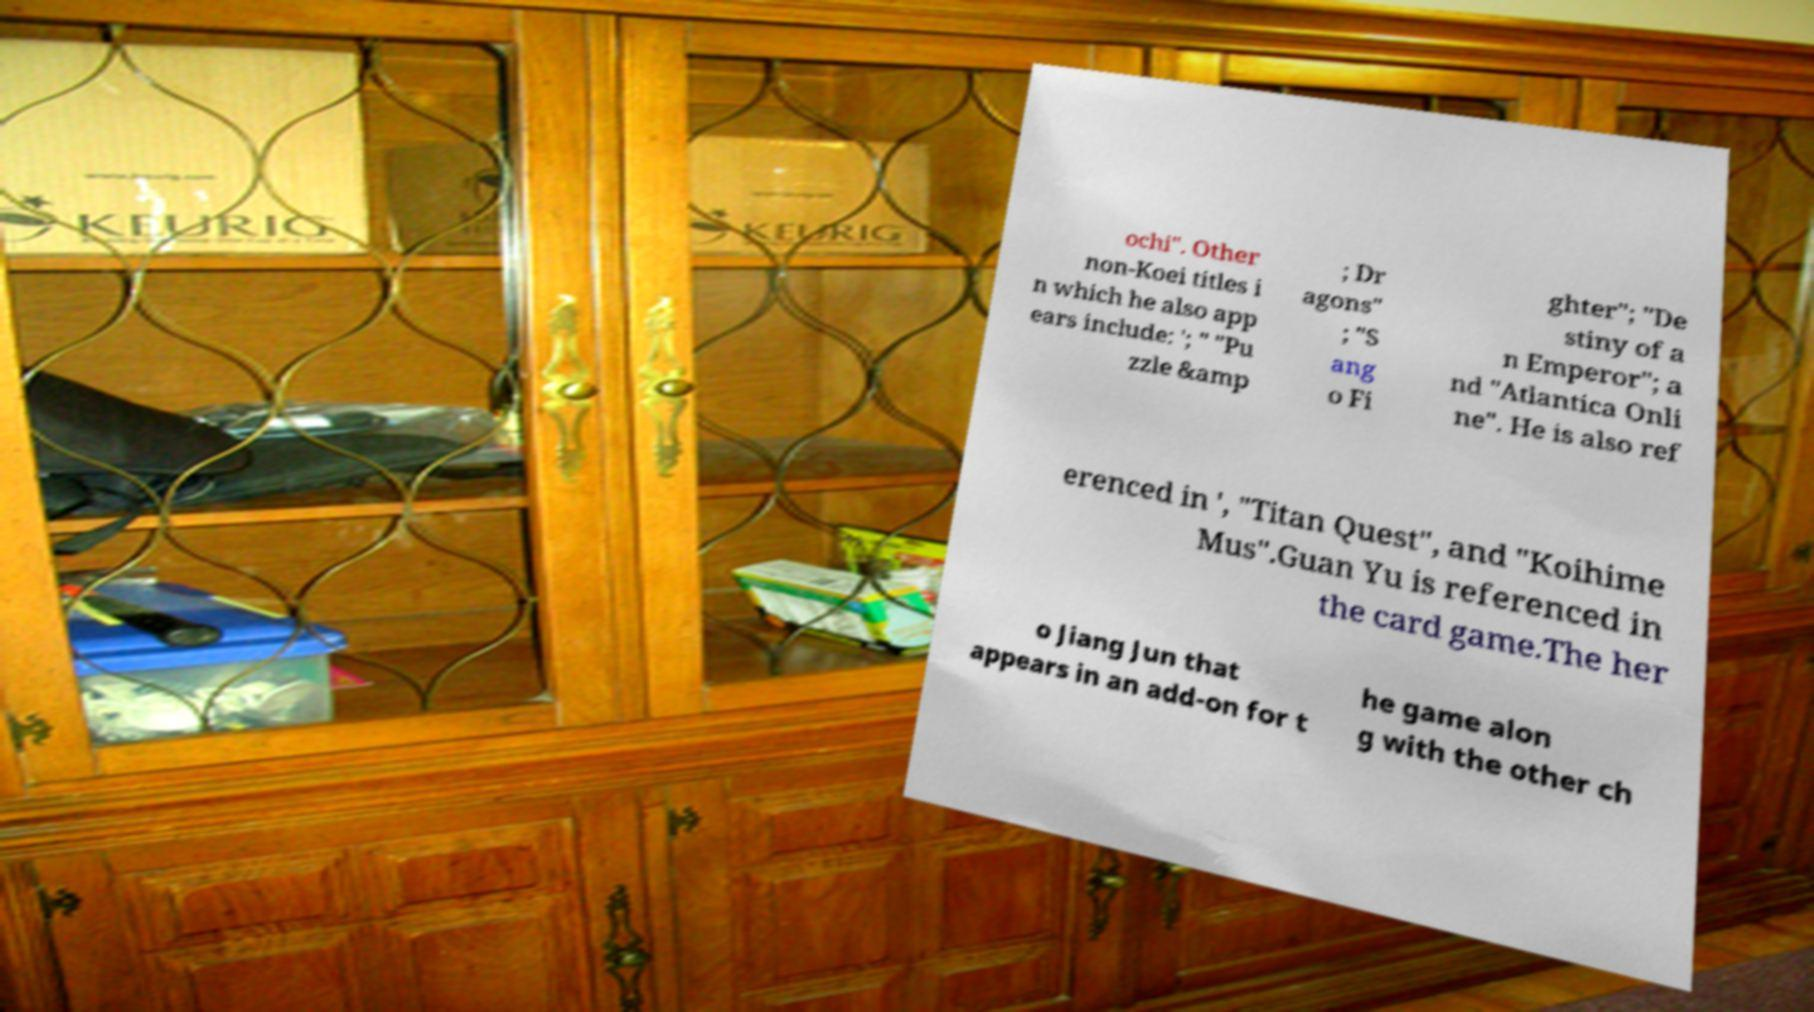There's text embedded in this image that I need extracted. Can you transcribe it verbatim? ochi". Other non-Koei titles i n which he also app ears include: '; " "Pu zzle &amp ; Dr agons" ; "S ang o Fi ghter"; "De stiny of a n Emperor"; a nd "Atlantica Onli ne". He is also ref erenced in ', "Titan Quest", and "Koihime Mus".Guan Yu is referenced in the card game.The her o Jiang Jun that appears in an add-on for t he game alon g with the other ch 